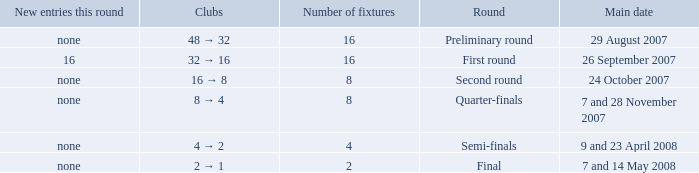What is the Clubs when there are 4 for the number of fixtures? 4 → 2. 